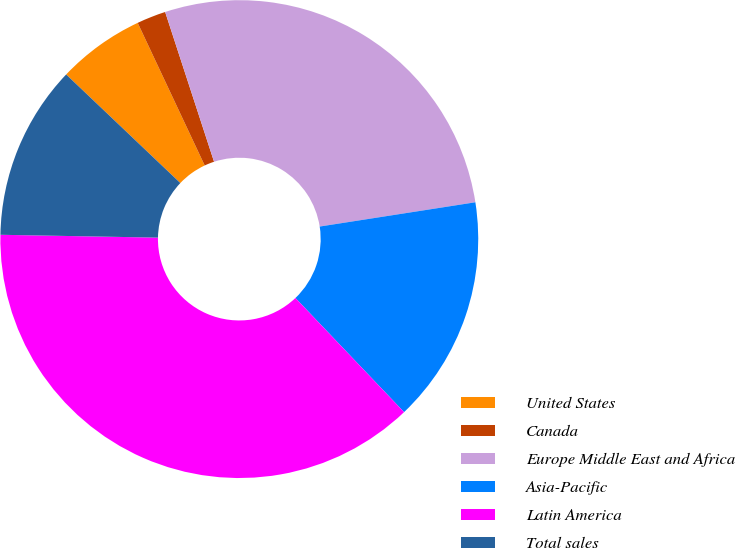Convert chart to OTSL. <chart><loc_0><loc_0><loc_500><loc_500><pie_chart><fcel>United States<fcel>Canada<fcel>Europe Middle East and Africa<fcel>Asia-Pacific<fcel>Latin America<fcel>Total sales<nl><fcel>5.91%<fcel>1.97%<fcel>27.56%<fcel>15.35%<fcel>37.4%<fcel>11.81%<nl></chart> 